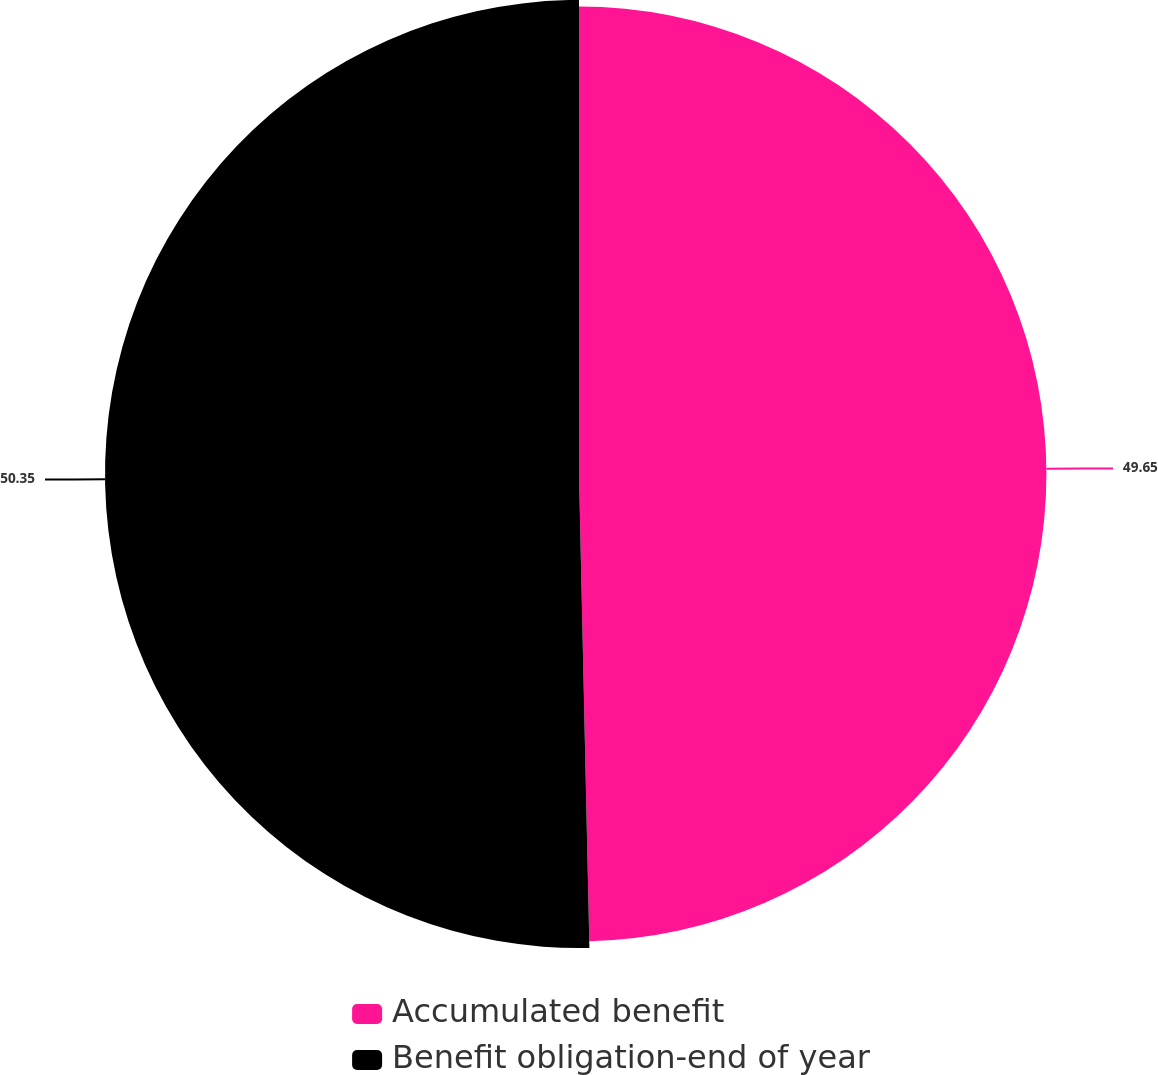Convert chart. <chart><loc_0><loc_0><loc_500><loc_500><pie_chart><fcel>Accumulated benefit<fcel>Benefit obligation-end of year<nl><fcel>49.65%<fcel>50.35%<nl></chart> 